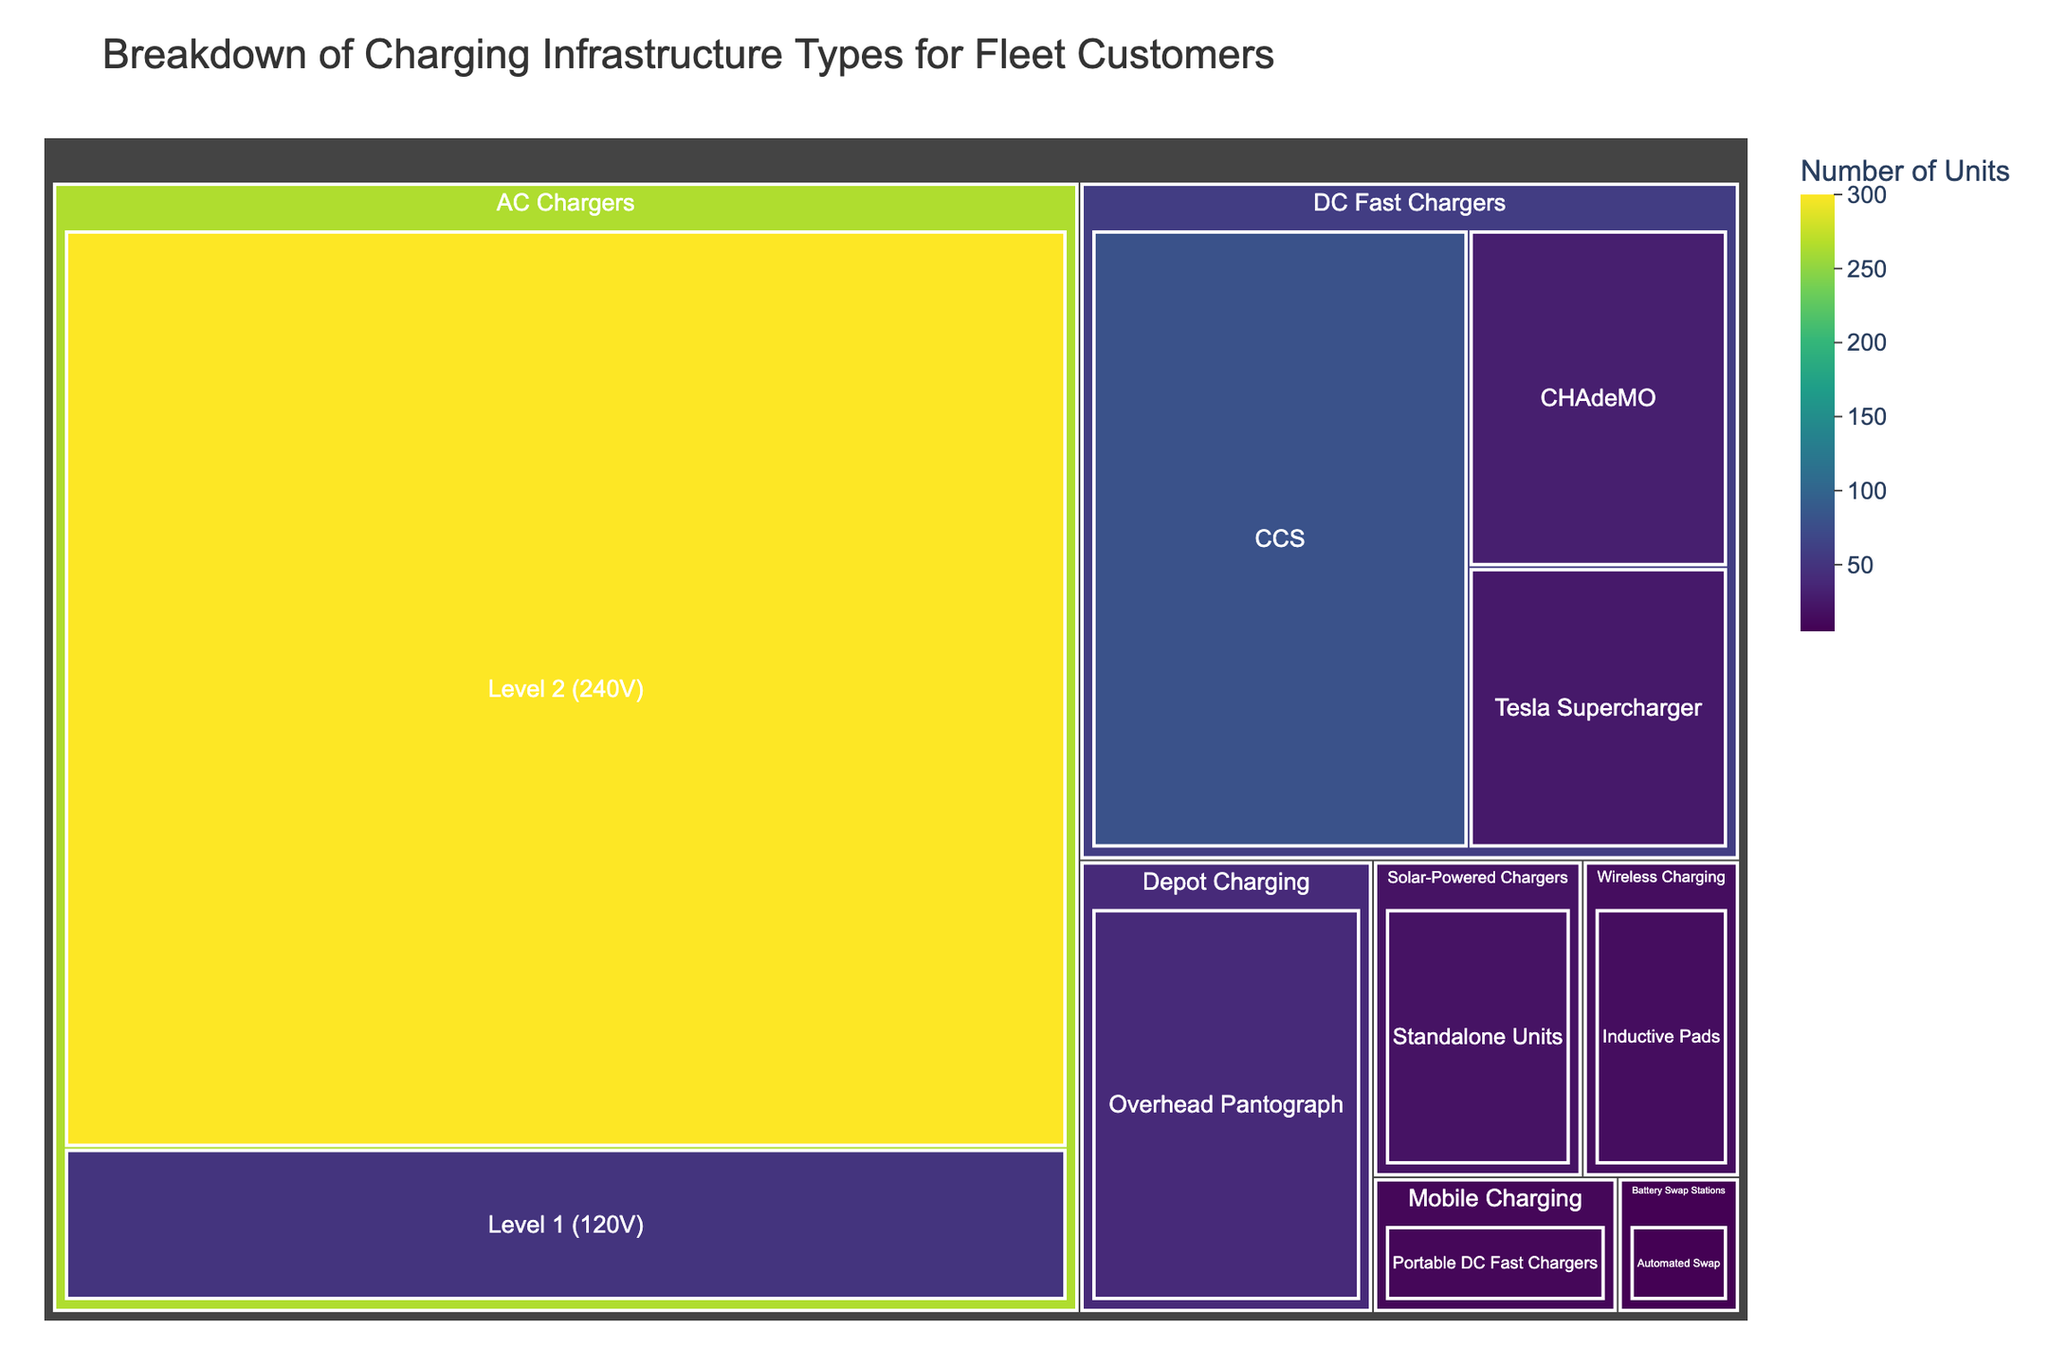What's the title of the treemap? The title of the treemap is typically located at the top of the figure, indicating what the chart is about.
Answer: Breakdown of Charging Infrastructure Types for Fleet Customers Which category has the highest number of units installed? To find this, look for the largest section in the treemap and check its label.
Answer: AC Chargers How many types of DC Fast Chargers are there? Count the subcategories under DC Fast Chargers in the treemap. There are three types: CHAdeMO, CCS, and Tesla Supercharger.
Answer: 3 What is the sum of all units for DC Fast Chargers? Add the values for CHAdeMO, CCS, and Tesla Supercharger under the DC Fast Chargers category. (30 + 80 + 25)
Answer: 135 Compare the number of Level 1 (120V) AC Chargers to Level 2 (240V) AC Chargers. Which has more units? Check the values for Level 1 (120V) and Level 2 (240V) under AC Chargers and compare. Level 2 (240V) has 300 units, which is more than Level 1 (120V) with 50 units.
Answer: Level 2 (240V) Which charging infrastructure type under Mobile Charging has the number of units listed? Identify the types under Mobile Charging and note the associated number. There is only one type under Mobile Charging: Portable DC Fast Chargers with 10 units.
Answer: Portable DC Fast Chargers What is the difference in the number of units between Level 2 (240V) AC Chargers and Overhead Pantograph Depot Chargers? Calculate the difference by subtracting the number of Overhead Pantograph Depot Chargers from Level 2 (240V) AC Chargers. (300 - 40)
Answer: 260 Which category has the least number of units? Look for the smallest section in the treemap and check its label. Battery Swap Stations with Automated Swap has the fewest units, 5.
Answer: Battery Swap Stations Calculate the average number of units per type within Solar-Powered Chargers. Since there is only one type under Solar-Powered Chargers, the average is the same as the number of units for Standalone Units.
Answer: 20 What is the total number of units installed across all categories? Sum the numbers of all units from each type in the treemap. (50 + 300 + 30 + 80 + 25 + 15 + 5 + 20 + 10 + 40)
Answer: 575 